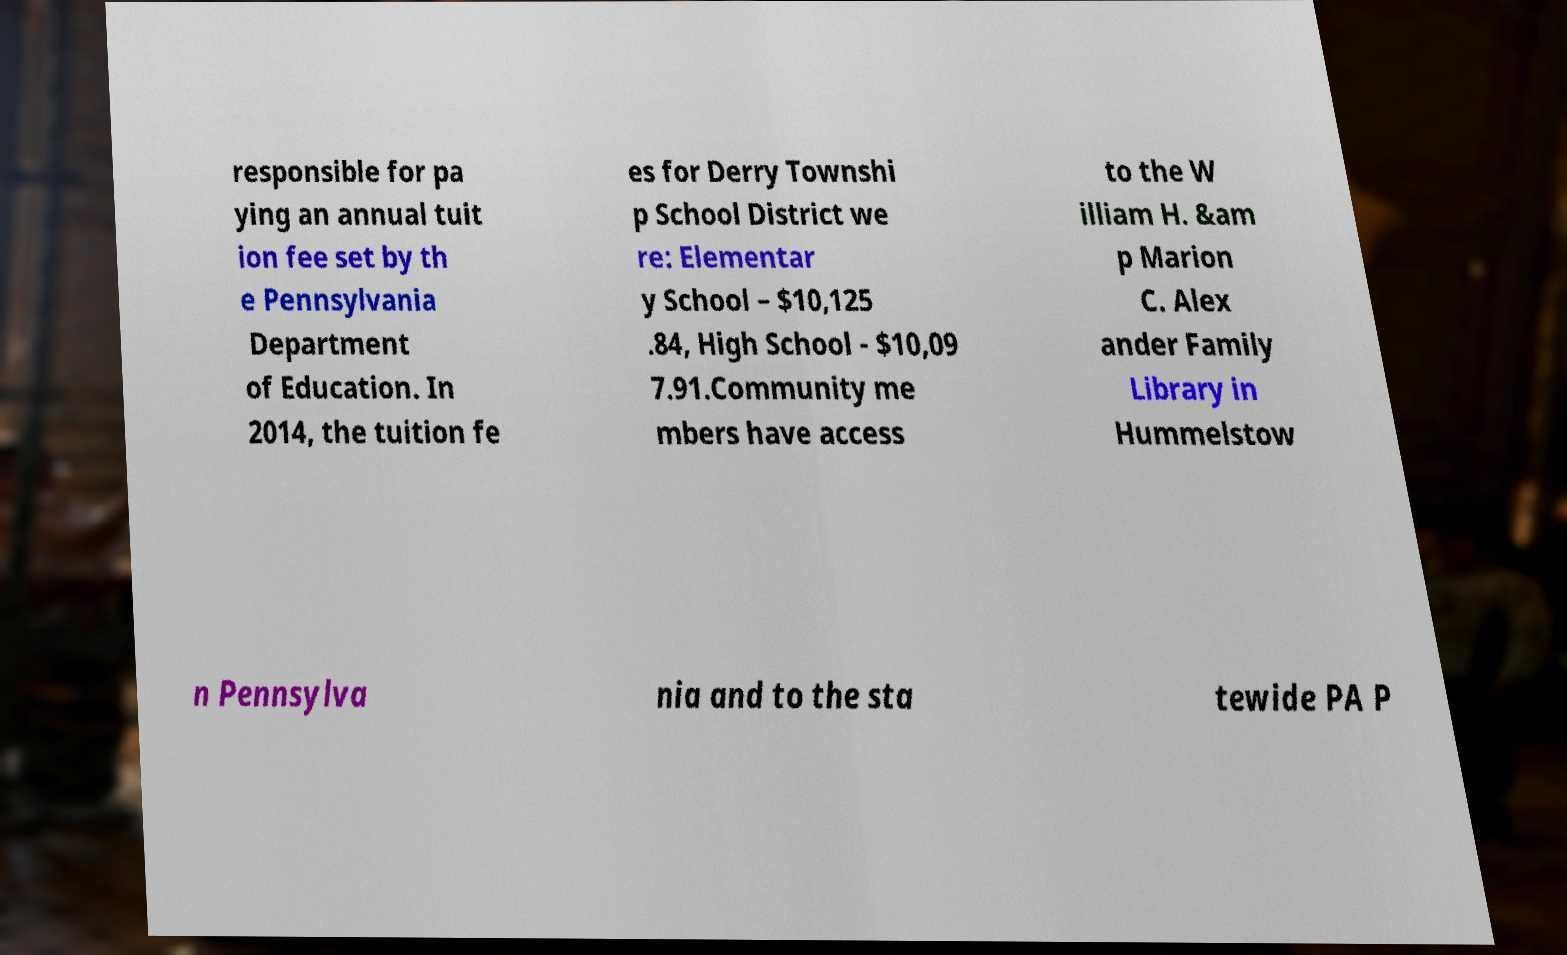Can you accurately transcribe the text from the provided image for me? responsible for pa ying an annual tuit ion fee set by th e Pennsylvania Department of Education. In 2014, the tuition fe es for Derry Townshi p School District we re: Elementar y School – $10,125 .84, High School - $10,09 7.91.Community me mbers have access to the W illiam H. &am p Marion C. Alex ander Family Library in Hummelstow n Pennsylva nia and to the sta tewide PA P 